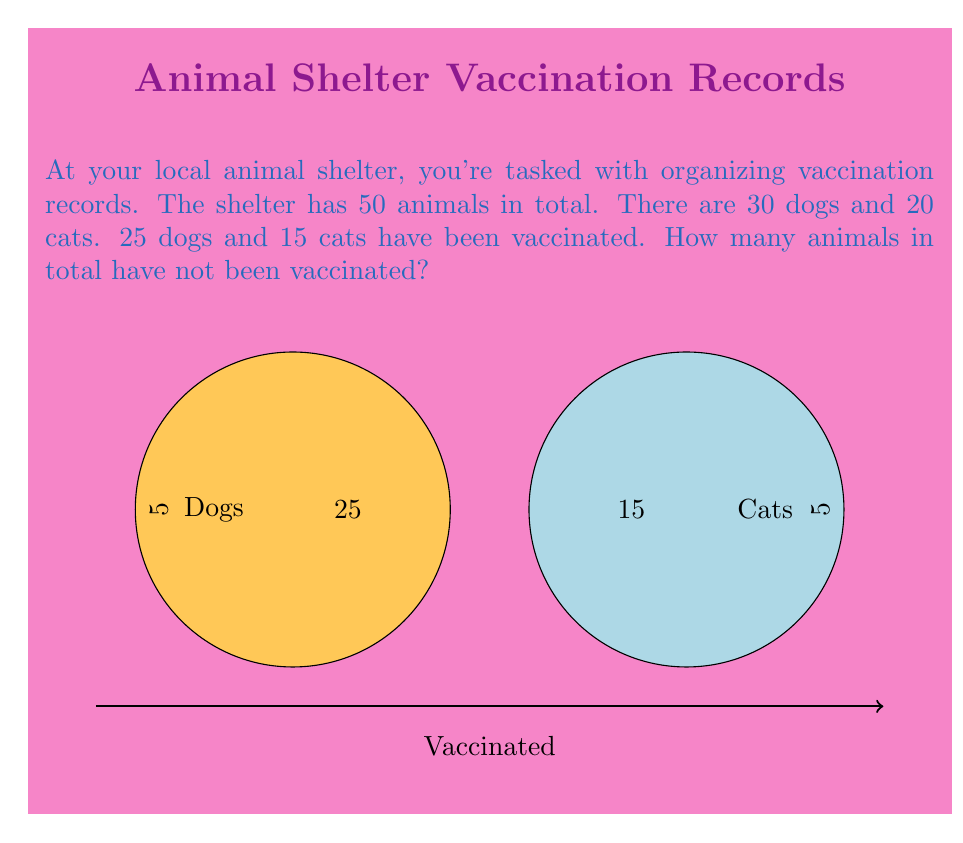Help me with this question. Let's approach this step-by-step:

1) First, let's define our sets:
   $D$ = set of dogs
   $C$ = set of cats
   $V$ = set of vaccinated animals

2) We're given:
   $|D| = 30$ (total number of dogs)
   $|C| = 20$ (total number of cats)
   $|D \cap V| = 25$ (vaccinated dogs)
   $|C \cap V| = 15$ (vaccinated cats)

3) To find the number of non-vaccinated animals, we need to subtract the vaccinated animals from the total:

   Non-vaccinated = Total - Vaccinated

4) Total animals:
   $|D \cup C| = |D| + |C| = 30 + 20 = 50$

5) Vaccinated animals:
   $|V| = |D \cap V| + |C \cap V| = 25 + 15 = 40$

6) Therefore, non-vaccinated animals:
   Non-vaccinated = $50 - 40 = 10$
Answer: 10 